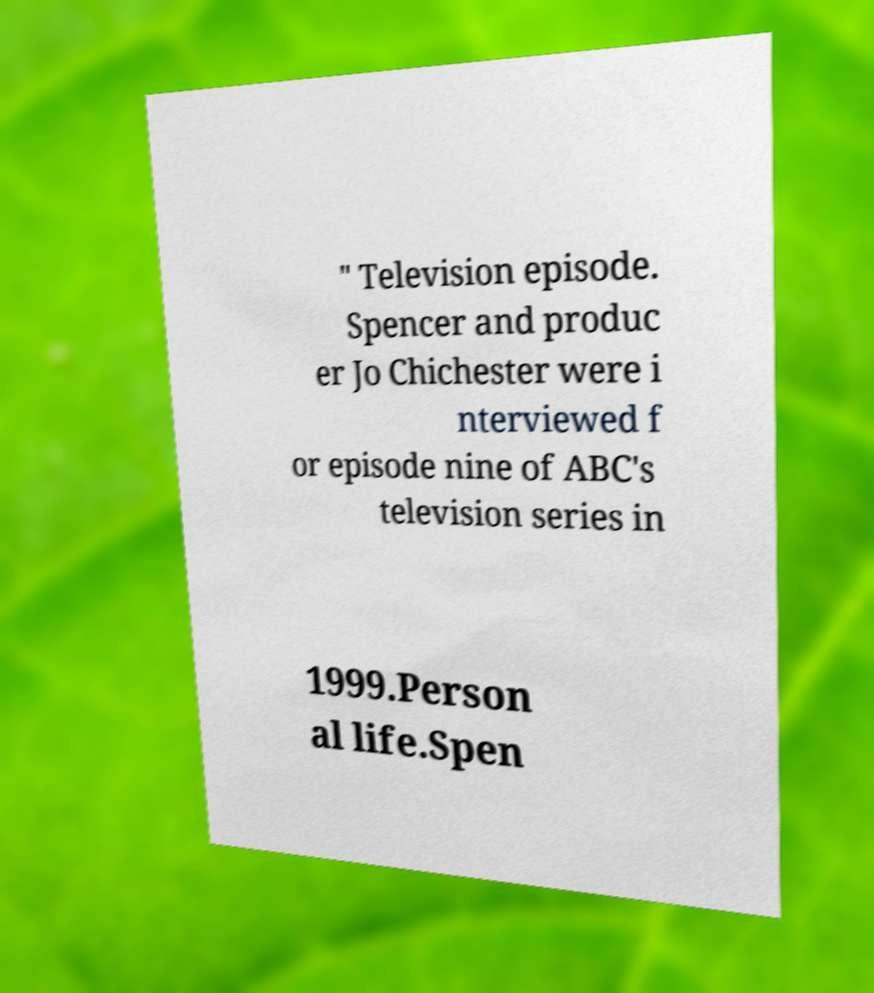For documentation purposes, I need the text within this image transcribed. Could you provide that? " Television episode. Spencer and produc er Jo Chichester were i nterviewed f or episode nine of ABC's television series in 1999.Person al life.Spen 